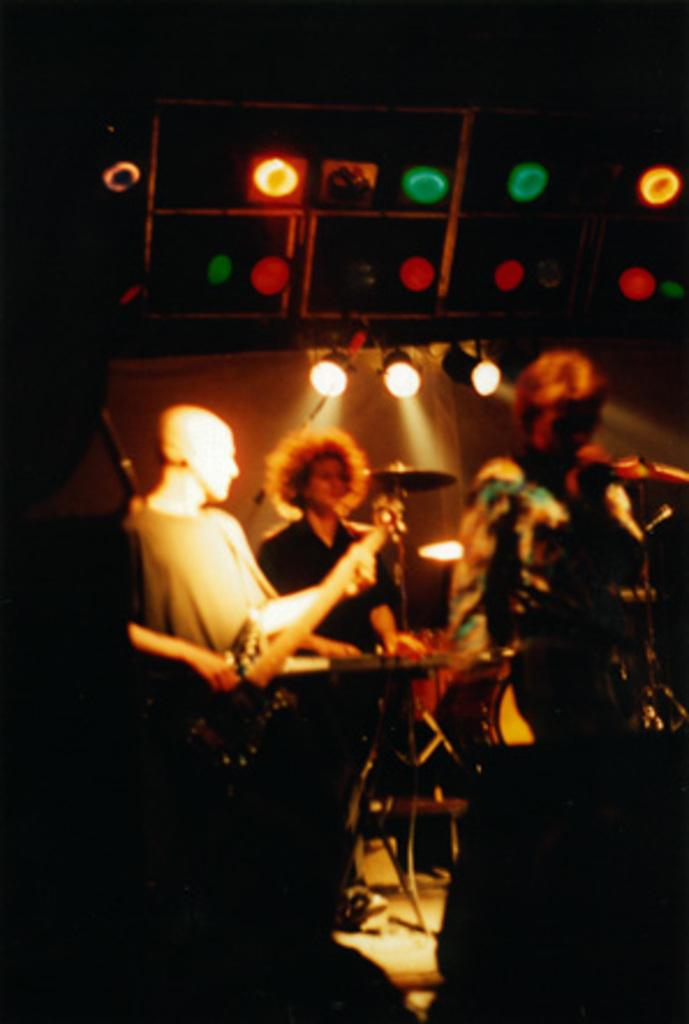What are the persons in the image doing? The persons in the image are playing instruments on a stage. What can be seen in the background of the image? There are lights in the background of the image. What type of humor can be seen in the pencil sketch on the wire in the image? There is no pencil sketch or wire present in the image, and therefore no humor can be observed. 